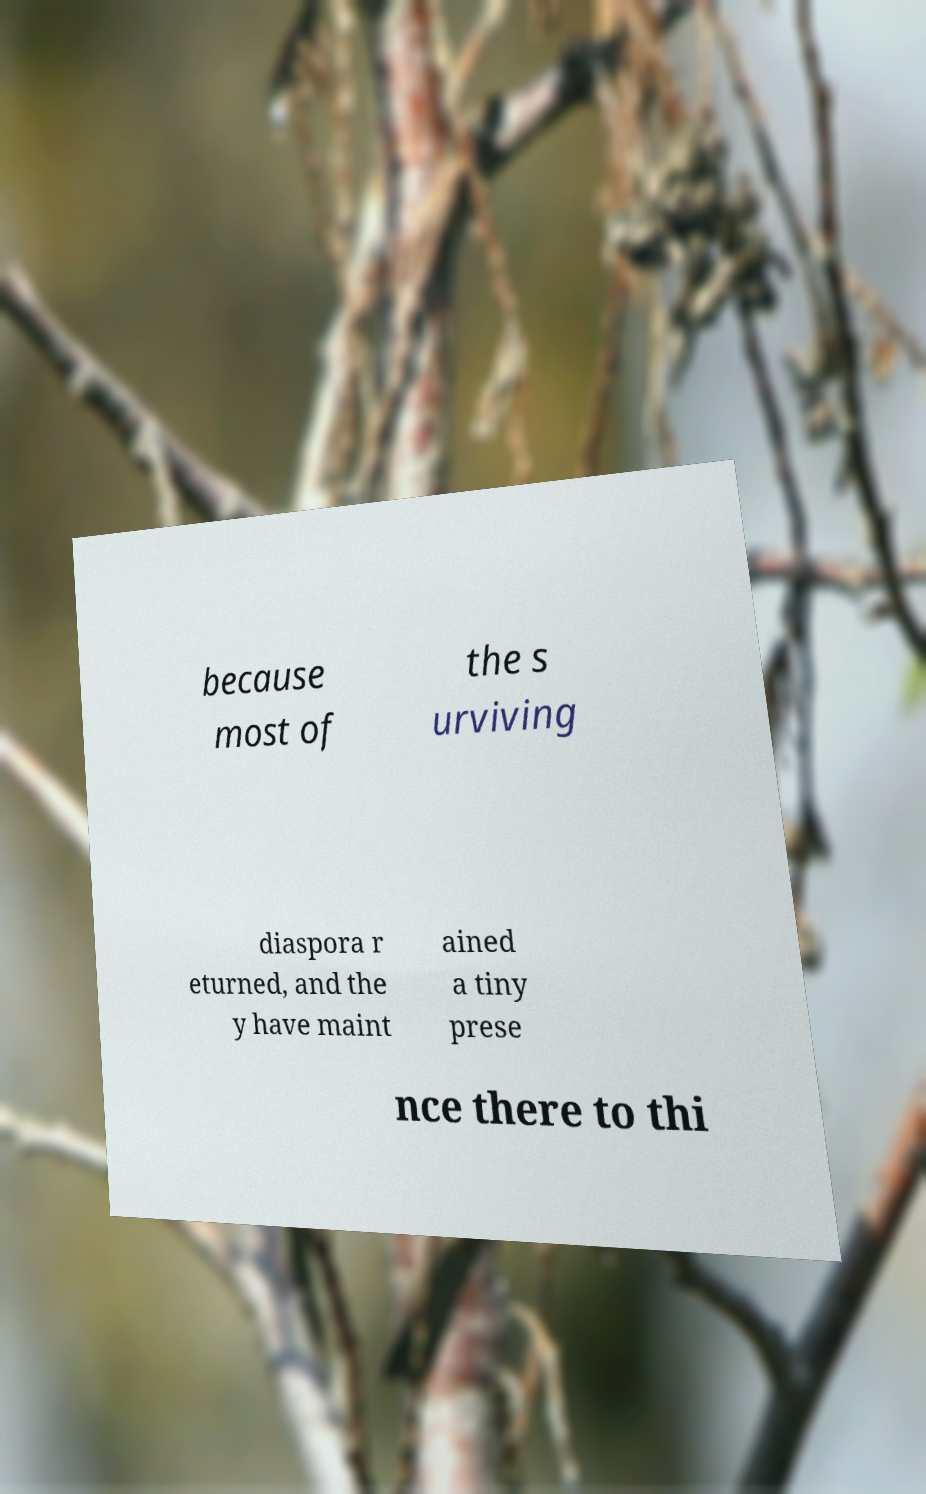For documentation purposes, I need the text within this image transcribed. Could you provide that? because most of the s urviving diaspora r eturned, and the y have maint ained a tiny prese nce there to thi 